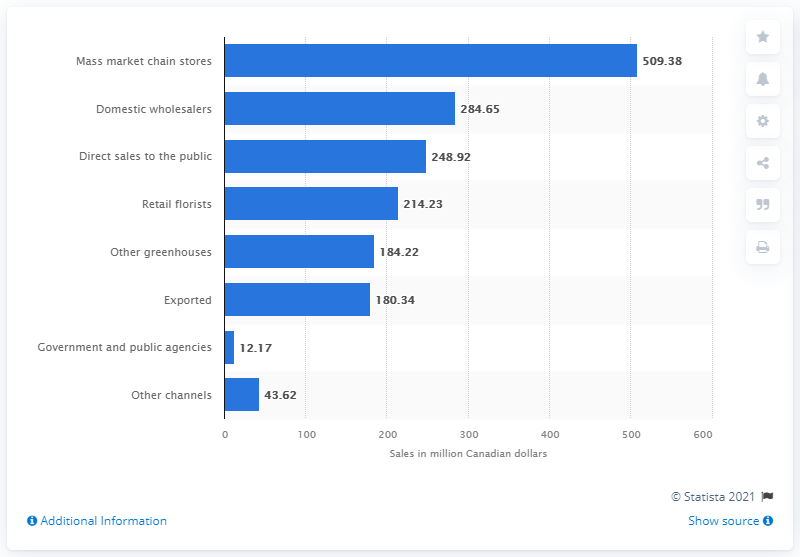Specify some key components in this picture. Mass market chains in Canada sold a total of CAD 509.38 million in flowers and plants in 2020. 